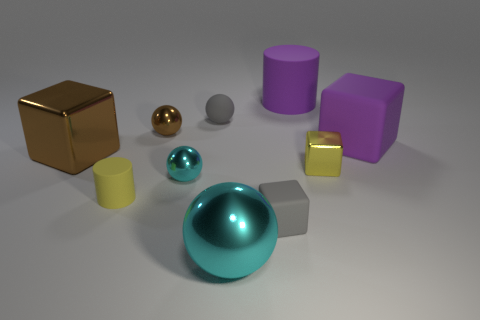Subtract 1 cubes. How many cubes are left? 3 Subtract all cylinders. How many objects are left? 8 Add 3 yellow metal things. How many yellow metal things exist? 4 Subtract 1 purple cylinders. How many objects are left? 9 Subtract all blue objects. Subtract all gray spheres. How many objects are left? 9 Add 9 yellow cubes. How many yellow cubes are left? 10 